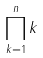Convert formula to latex. <formula><loc_0><loc_0><loc_500><loc_500>\prod _ { k = 1 } ^ { n } k</formula> 